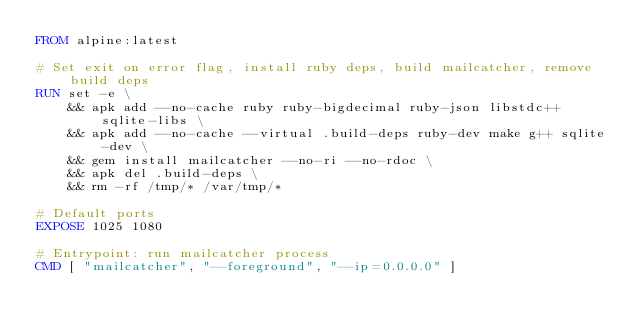Convert code to text. <code><loc_0><loc_0><loc_500><loc_500><_Dockerfile_>FROM alpine:latest

# Set exit on error flag, install ruby deps, build mailcatcher, remove build deps
RUN set -e \
    && apk add --no-cache ruby ruby-bigdecimal ruby-json libstdc++ sqlite-libs \
    && apk add --no-cache --virtual .build-deps ruby-dev make g++ sqlite-dev \
    && gem install mailcatcher --no-ri --no-rdoc \
    && apk del .build-deps \
    && rm -rf /tmp/* /var/tmp/*

# Default ports
EXPOSE 1025 1080

# Entrypoint: run mailcatcher process
CMD [ "mailcatcher", "--foreground", "--ip=0.0.0.0" ]
</code> 